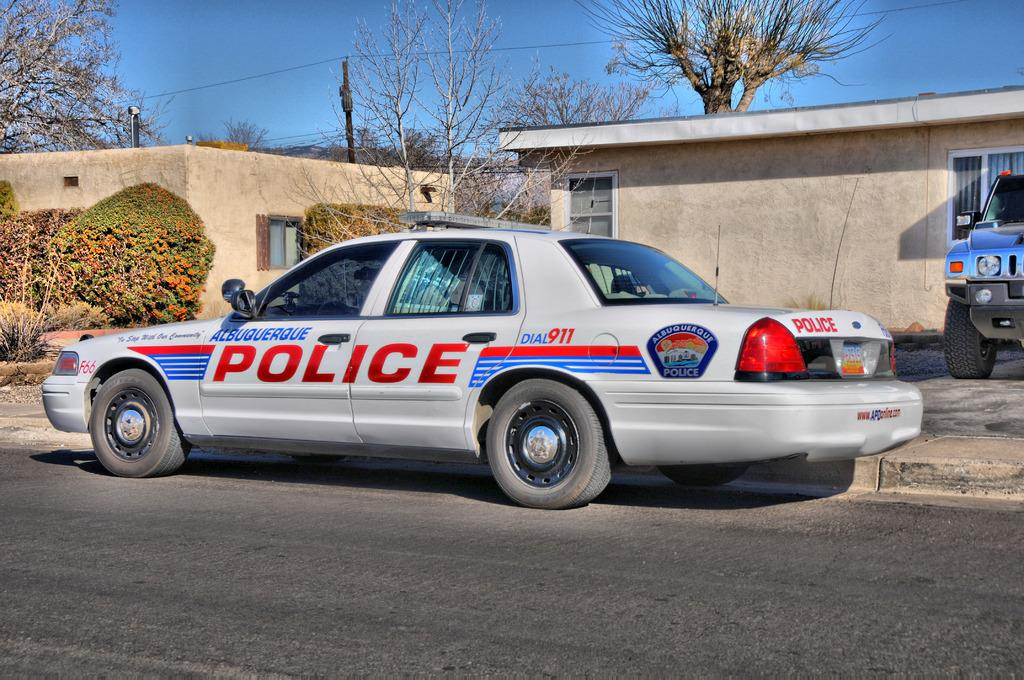<image>
Render a clear and concise summary of the photo. An Albuquerque police car sits parked on the side of the road. 